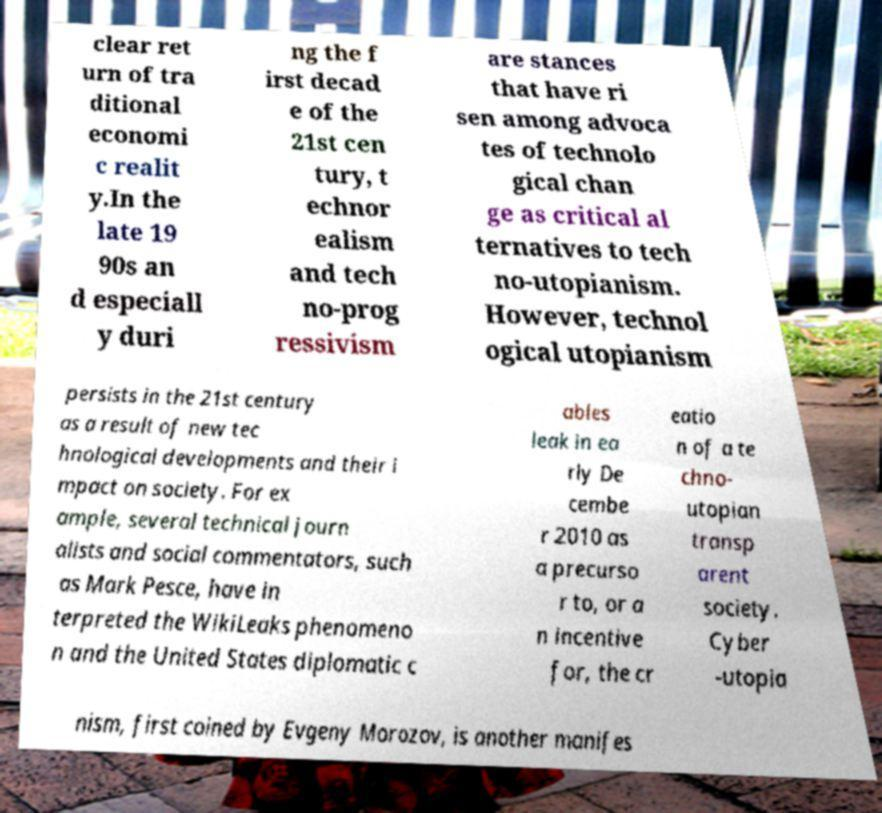Could you assist in decoding the text presented in this image and type it out clearly? clear ret urn of tra ditional economi c realit y.In the late 19 90s an d especiall y duri ng the f irst decad e of the 21st cen tury, t echnor ealism and tech no-prog ressivism are stances that have ri sen among advoca tes of technolo gical chan ge as critical al ternatives to tech no-utopianism. However, technol ogical utopianism persists in the 21st century as a result of new tec hnological developments and their i mpact on society. For ex ample, several technical journ alists and social commentators, such as Mark Pesce, have in terpreted the WikiLeaks phenomeno n and the United States diplomatic c ables leak in ea rly De cembe r 2010 as a precurso r to, or a n incentive for, the cr eatio n of a te chno- utopian transp arent society. Cyber -utopia nism, first coined by Evgeny Morozov, is another manifes 